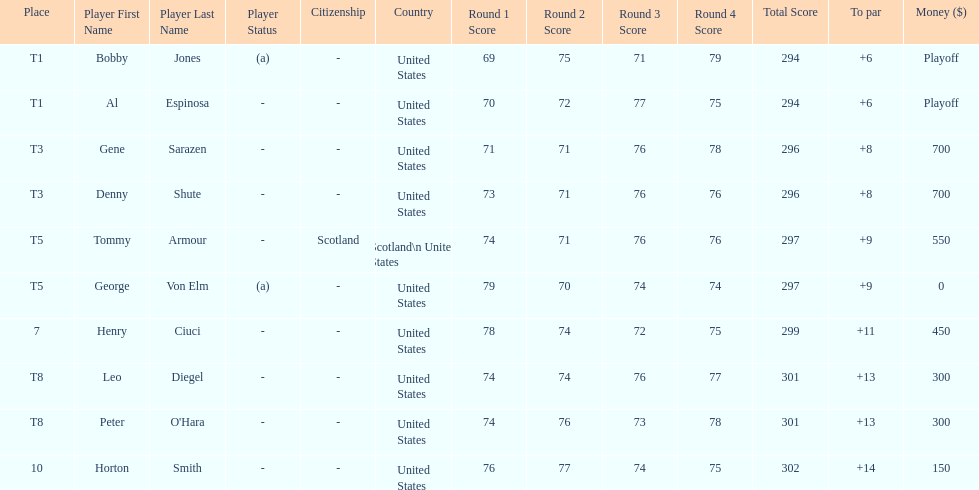Did tommy armour place above or below denny shute? Below. 